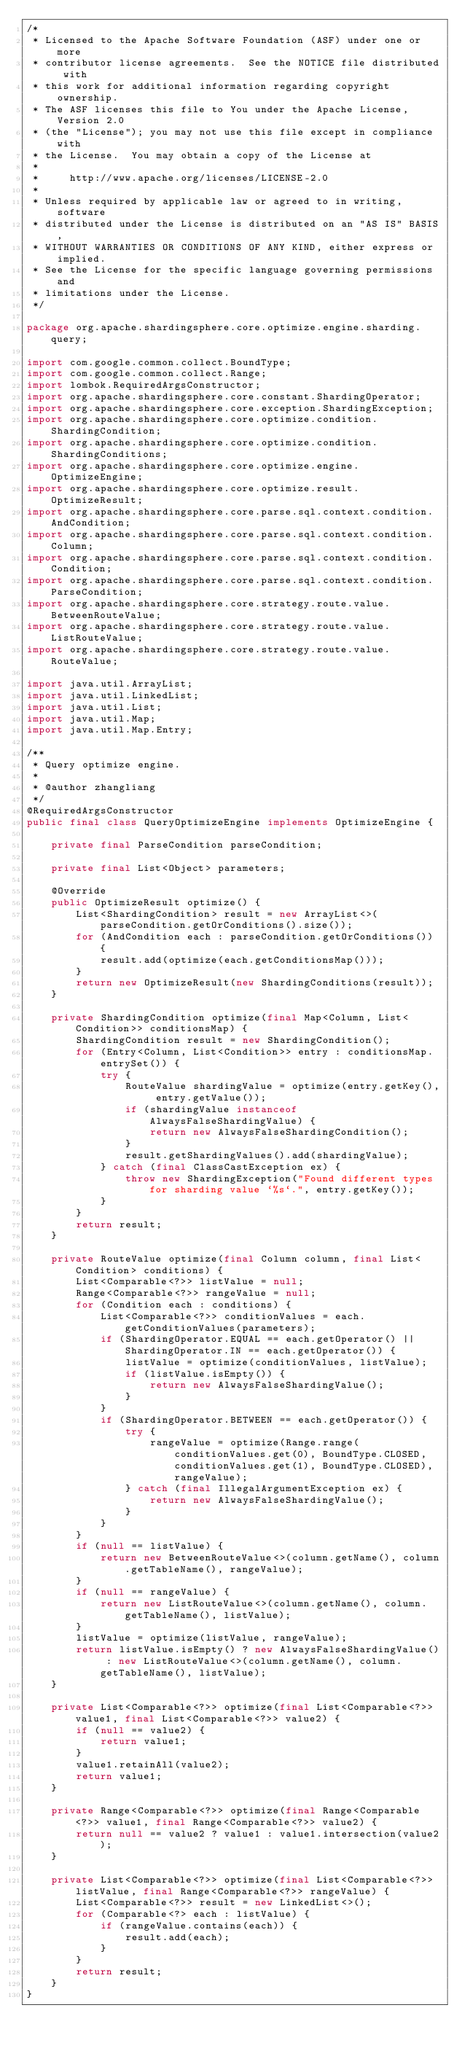Convert code to text. <code><loc_0><loc_0><loc_500><loc_500><_Java_>/*
 * Licensed to the Apache Software Foundation (ASF) under one or more
 * contributor license agreements.  See the NOTICE file distributed with
 * this work for additional information regarding copyright ownership.
 * The ASF licenses this file to You under the Apache License, Version 2.0
 * (the "License"); you may not use this file except in compliance with
 * the License.  You may obtain a copy of the License at
 *
 *     http://www.apache.org/licenses/LICENSE-2.0
 *
 * Unless required by applicable law or agreed to in writing, software
 * distributed under the License is distributed on an "AS IS" BASIS,
 * WITHOUT WARRANTIES OR CONDITIONS OF ANY KIND, either express or implied.
 * See the License for the specific language governing permissions and
 * limitations under the License.
 */

package org.apache.shardingsphere.core.optimize.engine.sharding.query;

import com.google.common.collect.BoundType;
import com.google.common.collect.Range;
import lombok.RequiredArgsConstructor;
import org.apache.shardingsphere.core.constant.ShardingOperator;
import org.apache.shardingsphere.core.exception.ShardingException;
import org.apache.shardingsphere.core.optimize.condition.ShardingCondition;
import org.apache.shardingsphere.core.optimize.condition.ShardingConditions;
import org.apache.shardingsphere.core.optimize.engine.OptimizeEngine;
import org.apache.shardingsphere.core.optimize.result.OptimizeResult;
import org.apache.shardingsphere.core.parse.sql.context.condition.AndCondition;
import org.apache.shardingsphere.core.parse.sql.context.condition.Column;
import org.apache.shardingsphere.core.parse.sql.context.condition.Condition;
import org.apache.shardingsphere.core.parse.sql.context.condition.ParseCondition;
import org.apache.shardingsphere.core.strategy.route.value.BetweenRouteValue;
import org.apache.shardingsphere.core.strategy.route.value.ListRouteValue;
import org.apache.shardingsphere.core.strategy.route.value.RouteValue;

import java.util.ArrayList;
import java.util.LinkedList;
import java.util.List;
import java.util.Map;
import java.util.Map.Entry;

/**
 * Query optimize engine.
 *
 * @author zhangliang
 */
@RequiredArgsConstructor
public final class QueryOptimizeEngine implements OptimizeEngine {
    
    private final ParseCondition parseCondition;
    
    private final List<Object> parameters;
    
    @Override
    public OptimizeResult optimize() {
        List<ShardingCondition> result = new ArrayList<>(parseCondition.getOrConditions().size());
        for (AndCondition each : parseCondition.getOrConditions()) {
            result.add(optimize(each.getConditionsMap()));
        }
        return new OptimizeResult(new ShardingConditions(result));
    }
    
    private ShardingCondition optimize(final Map<Column, List<Condition>> conditionsMap) {
        ShardingCondition result = new ShardingCondition();
        for (Entry<Column, List<Condition>> entry : conditionsMap.entrySet()) {
            try {
                RouteValue shardingValue = optimize(entry.getKey(), entry.getValue());
                if (shardingValue instanceof AlwaysFalseShardingValue) {
                    return new AlwaysFalseShardingCondition();
                }
                result.getShardingValues().add(shardingValue);
            } catch (final ClassCastException ex) {
                throw new ShardingException("Found different types for sharding value `%s`.", entry.getKey());
            }
        }
        return result;
    }
    
    private RouteValue optimize(final Column column, final List<Condition> conditions) {
        List<Comparable<?>> listValue = null;
        Range<Comparable<?>> rangeValue = null;
        for (Condition each : conditions) {
            List<Comparable<?>> conditionValues = each.getConditionValues(parameters);
            if (ShardingOperator.EQUAL == each.getOperator() || ShardingOperator.IN == each.getOperator()) {
                listValue = optimize(conditionValues, listValue);
                if (listValue.isEmpty()) {
                    return new AlwaysFalseShardingValue();
                }
            }
            if (ShardingOperator.BETWEEN == each.getOperator()) {
                try {
                    rangeValue = optimize(Range.range(conditionValues.get(0), BoundType.CLOSED, conditionValues.get(1), BoundType.CLOSED), rangeValue);
                } catch (final IllegalArgumentException ex) {
                    return new AlwaysFalseShardingValue();
                }
            }
        }
        if (null == listValue) {
            return new BetweenRouteValue<>(column.getName(), column.getTableName(), rangeValue);
        }
        if (null == rangeValue) {
            return new ListRouteValue<>(column.getName(), column.getTableName(), listValue);
        }
        listValue = optimize(listValue, rangeValue);
        return listValue.isEmpty() ? new AlwaysFalseShardingValue() : new ListRouteValue<>(column.getName(), column.getTableName(), listValue);
    }
    
    private List<Comparable<?>> optimize(final List<Comparable<?>> value1, final List<Comparable<?>> value2) {
        if (null == value2) {
            return value1;
        }
        value1.retainAll(value2);
        return value1;
    }
    
    private Range<Comparable<?>> optimize(final Range<Comparable<?>> value1, final Range<Comparable<?>> value2) {
        return null == value2 ? value1 : value1.intersection(value2);
    }
    
    private List<Comparable<?>> optimize(final List<Comparable<?>> listValue, final Range<Comparable<?>> rangeValue) {
        List<Comparable<?>> result = new LinkedList<>();
        for (Comparable<?> each : listValue) {
            if (rangeValue.contains(each)) {
                result.add(each);
            }
        }
        return result;
    }
}
</code> 